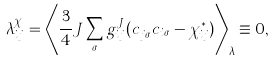<formula> <loc_0><loc_0><loc_500><loc_500>\lambda ^ { \chi } _ { i j } = \left \langle \frac { 3 } { 4 } J \sum _ { \sigma } g ^ { J } _ { i j } ( c _ { j \sigma } ^ { \dag } c _ { i \sigma } - \chi _ { i j } ^ { \ast } ) \right \rangle _ { \lambda } \equiv 0 ,</formula> 